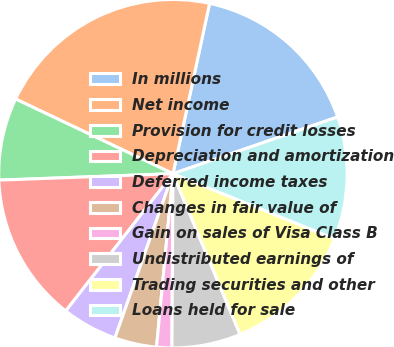Convert chart. <chart><loc_0><loc_0><loc_500><loc_500><pie_chart><fcel>In millions<fcel>Net income<fcel>Provision for credit losses<fcel>Depreciation and amortization<fcel>Deferred income taxes<fcel>Changes in fair value of<fcel>Gain on sales of Visa Class B<fcel>Undistributed earnings of<fcel>Trading securities and other<fcel>Loans held for sale<nl><fcel>16.35%<fcel>21.32%<fcel>7.64%<fcel>13.86%<fcel>5.15%<fcel>3.9%<fcel>1.41%<fcel>6.39%<fcel>12.61%<fcel>11.37%<nl></chart> 